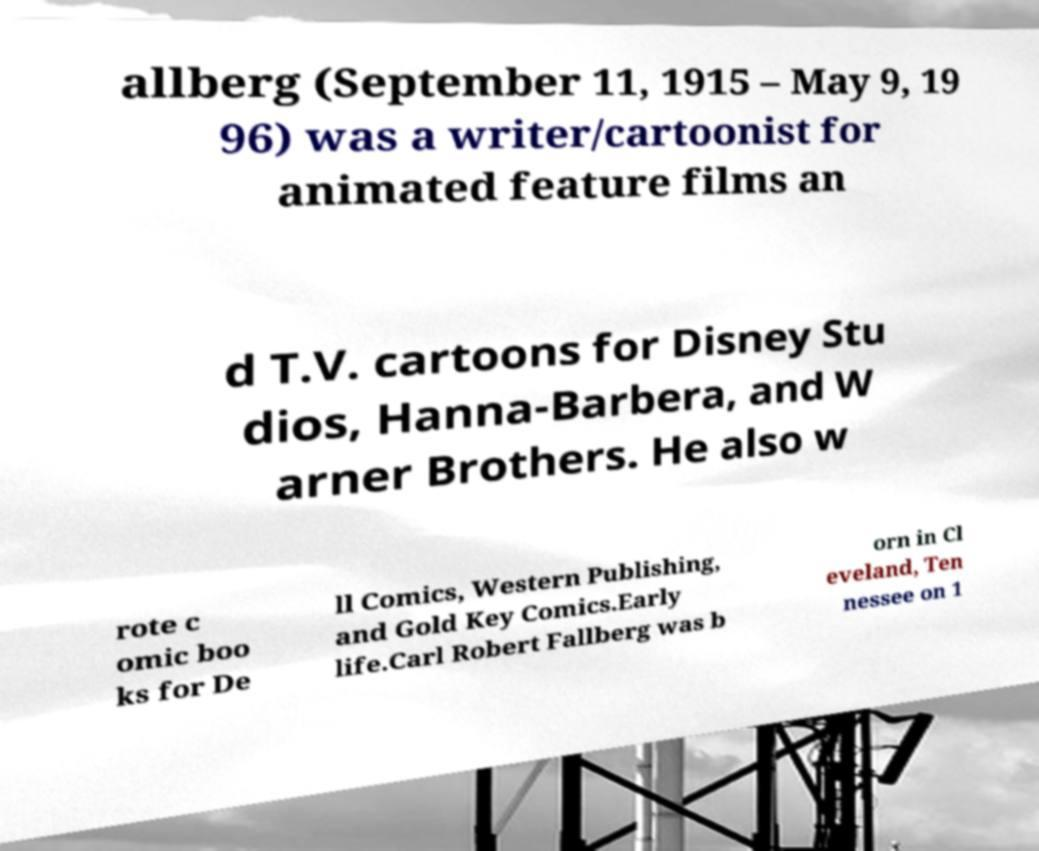Please read and relay the text visible in this image. What does it say? allberg (September 11, 1915 – May 9, 19 96) was a writer/cartoonist for animated feature films an d T.V. cartoons for Disney Stu dios, Hanna-Barbera, and W arner Brothers. He also w rote c omic boo ks for De ll Comics, Western Publishing, and Gold Key Comics.Early life.Carl Robert Fallberg was b orn in Cl eveland, Ten nessee on 1 